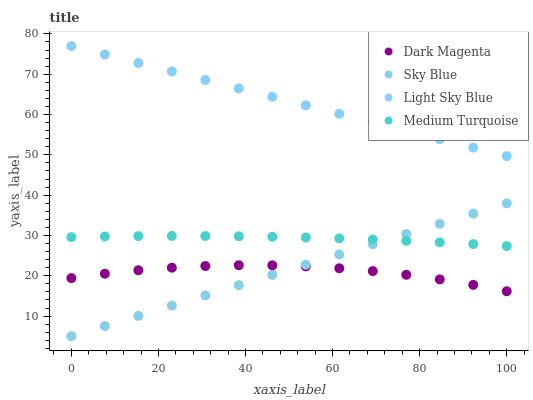Does Dark Magenta have the minimum area under the curve?
Answer yes or no. Yes. Does Light Sky Blue have the maximum area under the curve?
Answer yes or no. Yes. Does Light Sky Blue have the minimum area under the curve?
Answer yes or no. No. Does Dark Magenta have the maximum area under the curve?
Answer yes or no. No. Is Sky Blue the smoothest?
Answer yes or no. Yes. Is Dark Magenta the roughest?
Answer yes or no. Yes. Is Light Sky Blue the smoothest?
Answer yes or no. No. Is Light Sky Blue the roughest?
Answer yes or no. No. Does Sky Blue have the lowest value?
Answer yes or no. Yes. Does Dark Magenta have the lowest value?
Answer yes or no. No. Does Light Sky Blue have the highest value?
Answer yes or no. Yes. Does Dark Magenta have the highest value?
Answer yes or no. No. Is Medium Turquoise less than Light Sky Blue?
Answer yes or no. Yes. Is Medium Turquoise greater than Dark Magenta?
Answer yes or no. Yes. Does Sky Blue intersect Medium Turquoise?
Answer yes or no. Yes. Is Sky Blue less than Medium Turquoise?
Answer yes or no. No. Is Sky Blue greater than Medium Turquoise?
Answer yes or no. No. Does Medium Turquoise intersect Light Sky Blue?
Answer yes or no. No. 